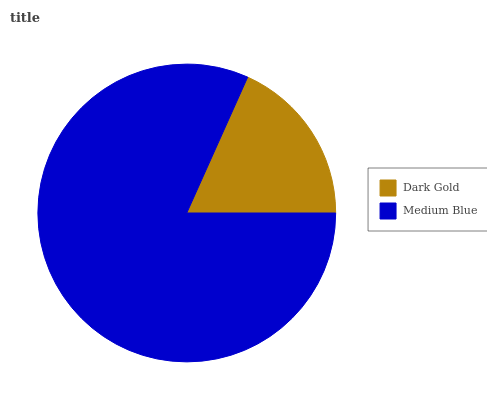Is Dark Gold the minimum?
Answer yes or no. Yes. Is Medium Blue the maximum?
Answer yes or no. Yes. Is Medium Blue the minimum?
Answer yes or no. No. Is Medium Blue greater than Dark Gold?
Answer yes or no. Yes. Is Dark Gold less than Medium Blue?
Answer yes or no. Yes. Is Dark Gold greater than Medium Blue?
Answer yes or no. No. Is Medium Blue less than Dark Gold?
Answer yes or no. No. Is Medium Blue the high median?
Answer yes or no. Yes. Is Dark Gold the low median?
Answer yes or no. Yes. Is Dark Gold the high median?
Answer yes or no. No. Is Medium Blue the low median?
Answer yes or no. No. 